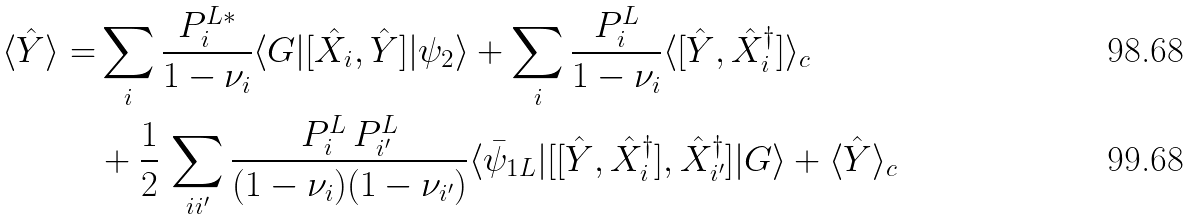Convert formula to latex. <formula><loc_0><loc_0><loc_500><loc_500>\langle { \hat { Y } } \rangle = & \sum _ { i } \frac { P _ { i } ^ { L * } } { 1 - \nu _ { i } } \langle G | [ \hat { X } _ { i } , \hat { Y } ] | \psi _ { 2 } \rangle + \sum _ { i } \frac { P _ { i } ^ { L } } { 1 - \nu _ { i } } \langle [ \hat { Y } , \hat { X } ^ { \dag } _ { i } ] \rangle _ { c } \\ & + \frac { 1 } { 2 } \, \sum _ { i i ^ { \prime } } \frac { P _ { i } ^ { L } \, P _ { i ^ { \prime } } ^ { L } } { ( 1 - \nu _ { i } ) ( 1 - \nu _ { i ^ { \prime } } ) } \langle \bar { \psi } _ { 1 L } | [ [ \hat { Y } , \hat { X } _ { i } ^ { \dag } ] , { \hat { X } } ^ { \dag } _ { i ^ { \prime } } ] | G \rangle + \langle \hat { Y } \rangle _ { c }</formula> 